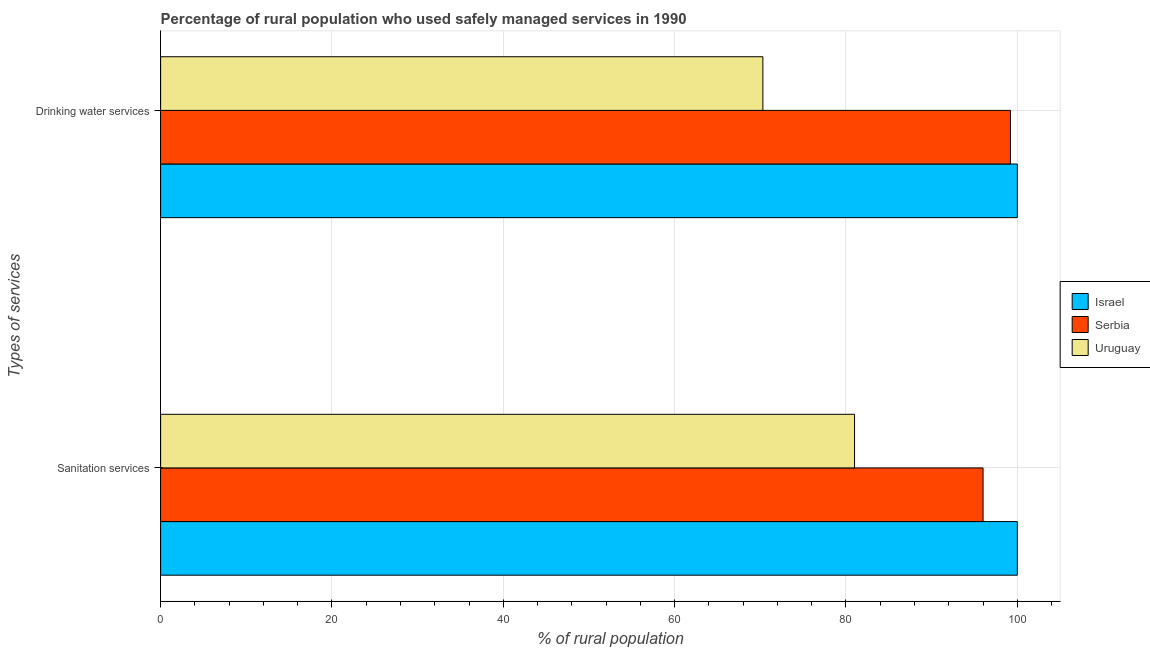How many different coloured bars are there?
Ensure brevity in your answer.  3. Are the number of bars per tick equal to the number of legend labels?
Keep it short and to the point. Yes. How many bars are there on the 1st tick from the top?
Offer a very short reply. 3. What is the label of the 2nd group of bars from the top?
Provide a succinct answer. Sanitation services. What is the percentage of rural population who used drinking water services in Serbia?
Your response must be concise. 99.2. Across all countries, what is the maximum percentage of rural population who used sanitation services?
Make the answer very short. 100. Across all countries, what is the minimum percentage of rural population who used sanitation services?
Your response must be concise. 81. In which country was the percentage of rural population who used drinking water services maximum?
Provide a short and direct response. Israel. In which country was the percentage of rural population who used drinking water services minimum?
Offer a terse response. Uruguay. What is the total percentage of rural population who used drinking water services in the graph?
Offer a very short reply. 269.5. What is the difference between the percentage of rural population who used drinking water services in Serbia and that in Uruguay?
Your answer should be compact. 28.9. What is the difference between the percentage of rural population who used sanitation services in Uruguay and the percentage of rural population who used drinking water services in Israel?
Provide a succinct answer. -19. What is the average percentage of rural population who used sanitation services per country?
Keep it short and to the point. 92.33. What is the difference between the percentage of rural population who used drinking water services and percentage of rural population who used sanitation services in Serbia?
Give a very brief answer. 3.2. In how many countries, is the percentage of rural population who used sanitation services greater than 28 %?
Offer a very short reply. 3. What is the ratio of the percentage of rural population who used drinking water services in Israel to that in Uruguay?
Your answer should be compact. 1.42. Is the percentage of rural population who used drinking water services in Serbia less than that in Uruguay?
Provide a short and direct response. No. What does the 3rd bar from the top in Drinking water services represents?
Keep it short and to the point. Israel. How many countries are there in the graph?
Offer a terse response. 3. Does the graph contain grids?
Give a very brief answer. Yes. How are the legend labels stacked?
Provide a short and direct response. Vertical. What is the title of the graph?
Your answer should be very brief. Percentage of rural population who used safely managed services in 1990. Does "Europe(all income levels)" appear as one of the legend labels in the graph?
Provide a succinct answer. No. What is the label or title of the X-axis?
Make the answer very short. % of rural population. What is the label or title of the Y-axis?
Provide a short and direct response. Types of services. What is the % of rural population in Serbia in Sanitation services?
Offer a very short reply. 96. What is the % of rural population of Serbia in Drinking water services?
Keep it short and to the point. 99.2. What is the % of rural population in Uruguay in Drinking water services?
Make the answer very short. 70.3. Across all Types of services, what is the maximum % of rural population in Israel?
Keep it short and to the point. 100. Across all Types of services, what is the maximum % of rural population of Serbia?
Your answer should be compact. 99.2. Across all Types of services, what is the minimum % of rural population of Israel?
Keep it short and to the point. 100. Across all Types of services, what is the minimum % of rural population of Serbia?
Offer a terse response. 96. Across all Types of services, what is the minimum % of rural population in Uruguay?
Provide a short and direct response. 70.3. What is the total % of rural population in Serbia in the graph?
Your answer should be very brief. 195.2. What is the total % of rural population of Uruguay in the graph?
Offer a very short reply. 151.3. What is the difference between the % of rural population in Israel in Sanitation services and that in Drinking water services?
Your answer should be very brief. 0. What is the difference between the % of rural population of Serbia in Sanitation services and that in Drinking water services?
Keep it short and to the point. -3.2. What is the difference between the % of rural population of Israel in Sanitation services and the % of rural population of Uruguay in Drinking water services?
Keep it short and to the point. 29.7. What is the difference between the % of rural population in Serbia in Sanitation services and the % of rural population in Uruguay in Drinking water services?
Keep it short and to the point. 25.7. What is the average % of rural population in Israel per Types of services?
Provide a short and direct response. 100. What is the average % of rural population of Serbia per Types of services?
Your response must be concise. 97.6. What is the average % of rural population in Uruguay per Types of services?
Give a very brief answer. 75.65. What is the difference between the % of rural population in Israel and % of rural population in Serbia in Sanitation services?
Your response must be concise. 4. What is the difference between the % of rural population of Israel and % of rural population of Uruguay in Sanitation services?
Offer a terse response. 19. What is the difference between the % of rural population of Israel and % of rural population of Serbia in Drinking water services?
Give a very brief answer. 0.8. What is the difference between the % of rural population of Israel and % of rural population of Uruguay in Drinking water services?
Your response must be concise. 29.7. What is the difference between the % of rural population in Serbia and % of rural population in Uruguay in Drinking water services?
Give a very brief answer. 28.9. What is the ratio of the % of rural population in Israel in Sanitation services to that in Drinking water services?
Offer a very short reply. 1. What is the ratio of the % of rural population in Serbia in Sanitation services to that in Drinking water services?
Provide a succinct answer. 0.97. What is the ratio of the % of rural population of Uruguay in Sanitation services to that in Drinking water services?
Provide a short and direct response. 1.15. What is the difference between the highest and the second highest % of rural population of Serbia?
Give a very brief answer. 3.2. What is the difference between the highest and the second highest % of rural population in Uruguay?
Your response must be concise. 10.7. What is the difference between the highest and the lowest % of rural population of Serbia?
Make the answer very short. 3.2. What is the difference between the highest and the lowest % of rural population of Uruguay?
Make the answer very short. 10.7. 